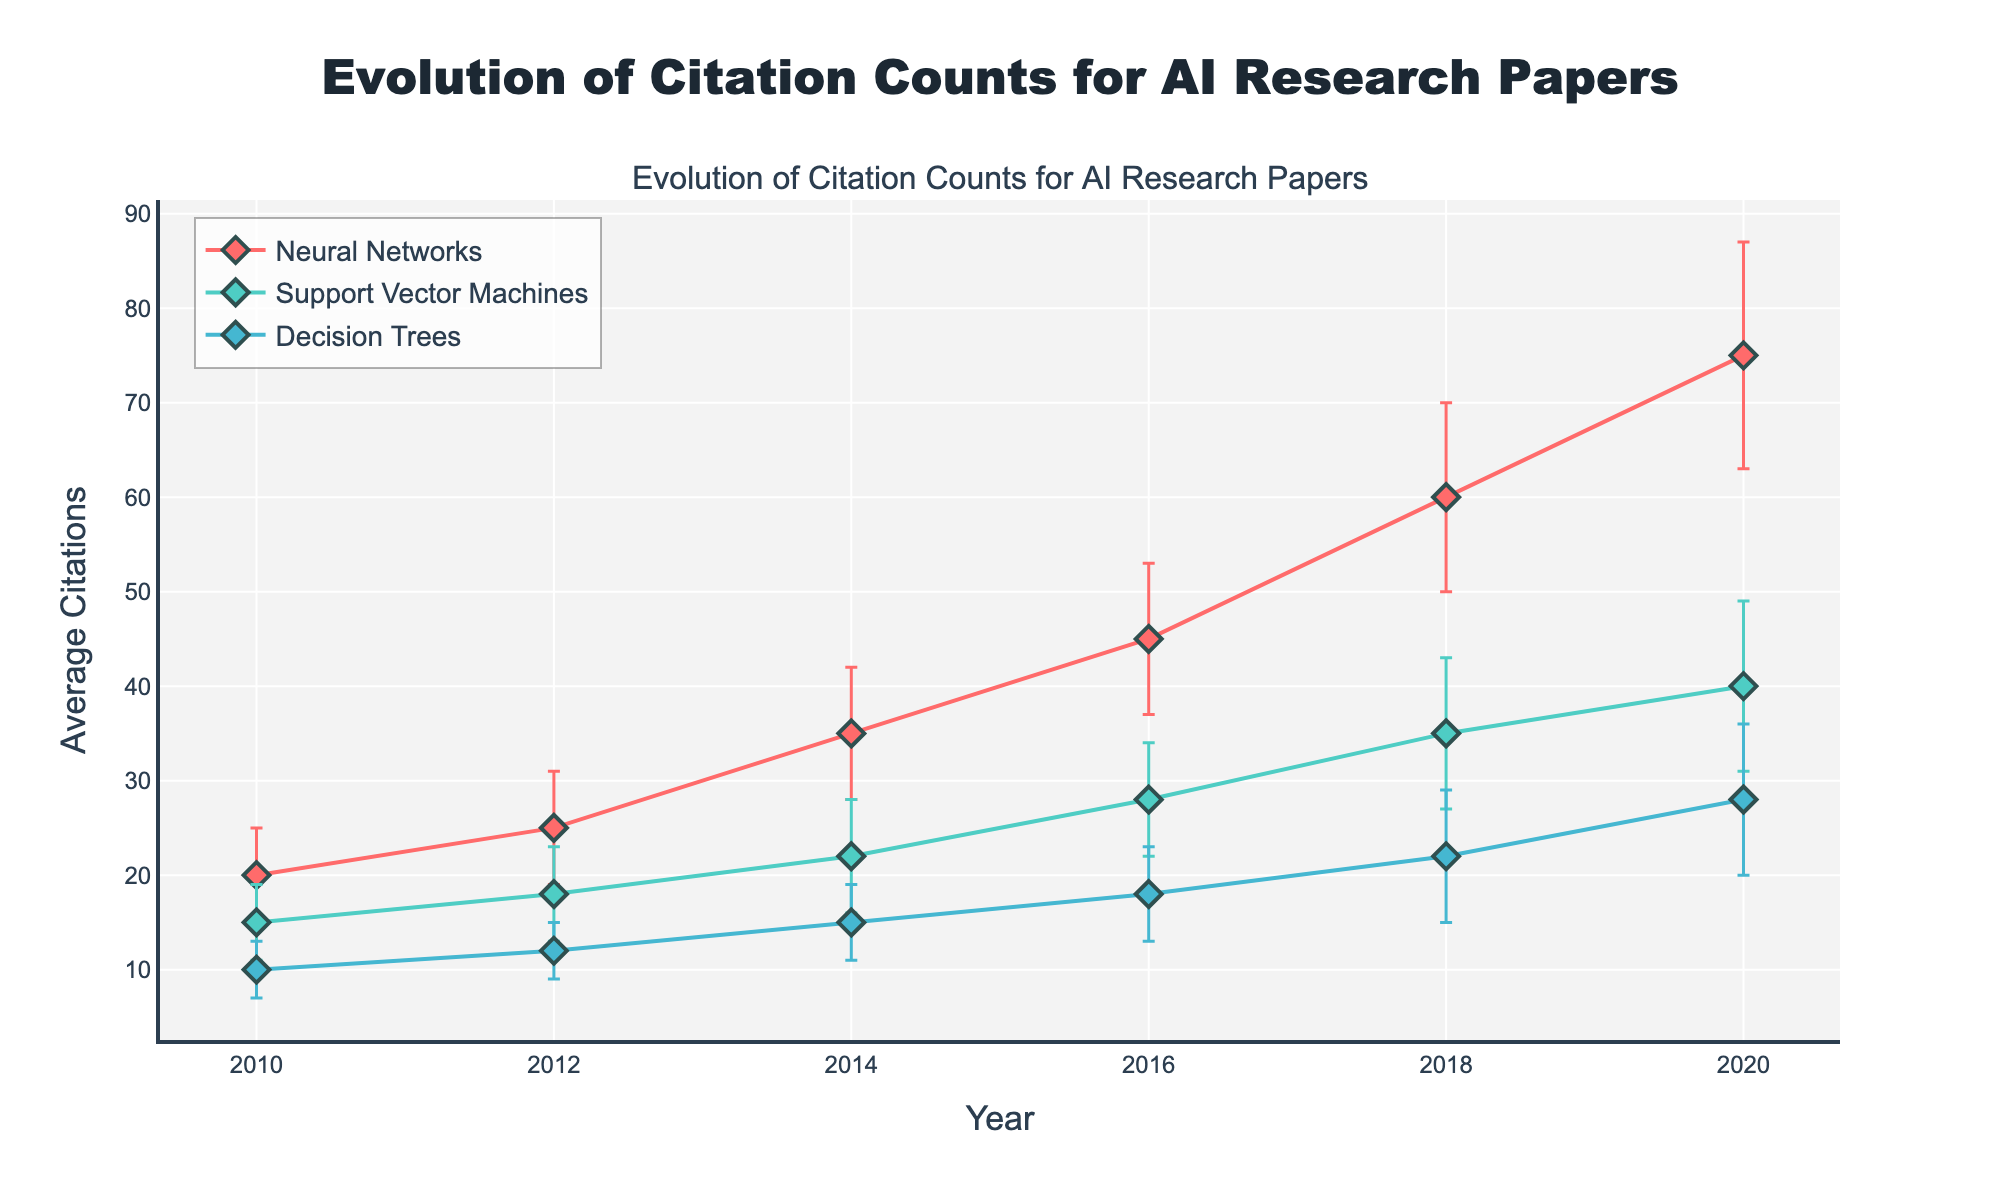What's the title of the figure? The title is located at the top of the figure and provides an overview of what the figure is about. In this case, it reads "Evolution of Citation Counts for AI Research Papers".
Answer: Evolution of Citation Counts for AI Research Papers What are the units on the x-axis? The x-axis denotes the variable that changes over time. From the figure, the units on the x-axis are years.
Answer: Years Which research topic has the highest average citations in 2020? Examine the y-values for the year 2020 across all research topics. The highest y-value corresponds to Neural Networks.
Answer: Neural Networks By how much did the average citations of Neural Networks increase from 2016 to 2018? First, find the average citations of Neural Networks for 2016 (45) and for 2018 (60). Subtract the 2016 value from the 2018 value (60 - 45).
Answer: 15 Which research topic has the smallest standard deviation in 2018? Look for the smallest error bar in the 2018 data points. Decision Trees has the smallest error bar with a standard deviation of 7.
Answer: Decision Trees How many research topics are represented in the figure? Count the different unique research topics listed in the legend or represented by different colored lines. There are three: Neural Networks, Support Vector Machines, and Decision Trees.
Answer: Three How does the trend of average citations for Support Vector Machines compare with Decision Trees from 2010 to 2020? Compare the line trends for both topics. Support Vector Machines consistently has higher average citations than Decision Trees, and both show an increasing trend over the years.
Answer: Higher and increasing trend Between 2014 and 2016, which research topic showed the largest increase in average citations? Calculate the difference in average citations between 2014 and 2016 for each topic (Neural Networks: 45-35=10, Support Vector Machines: 28-22=6, Decision Trees: 18-15=3). Neural Networks showed the largest increase of 10.
Answer: Neural Networks What is the average increase in citations for Neural Networks per year from 2010 to 2020? Calculate the average citations for Neural Networks in 2010 (20) and 2020 (75). Subtract the 2010 value from the 2020 value and divide by the number of years (75-20=55; 55/10=5.5).
Answer: 5.5 Which year has the highest overall variance in citations for all research topics combined? To find the year with the highest variance, add the variances (squared standard deviations) for each topic per year and compare. The highest combined value is in 2020.
Answer: 2020 